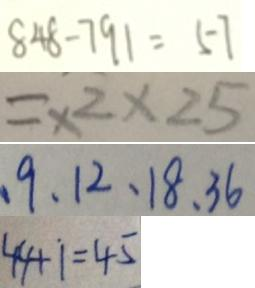Convert formula to latex. <formula><loc_0><loc_0><loc_500><loc_500>8 4 8 - 7 9 1 = 5 7 
 = \times 2 \times 2 5 
 、 9 、 1 2 、 1 8 、 3 6 
 4 4 + 1 = 4 5</formula> 